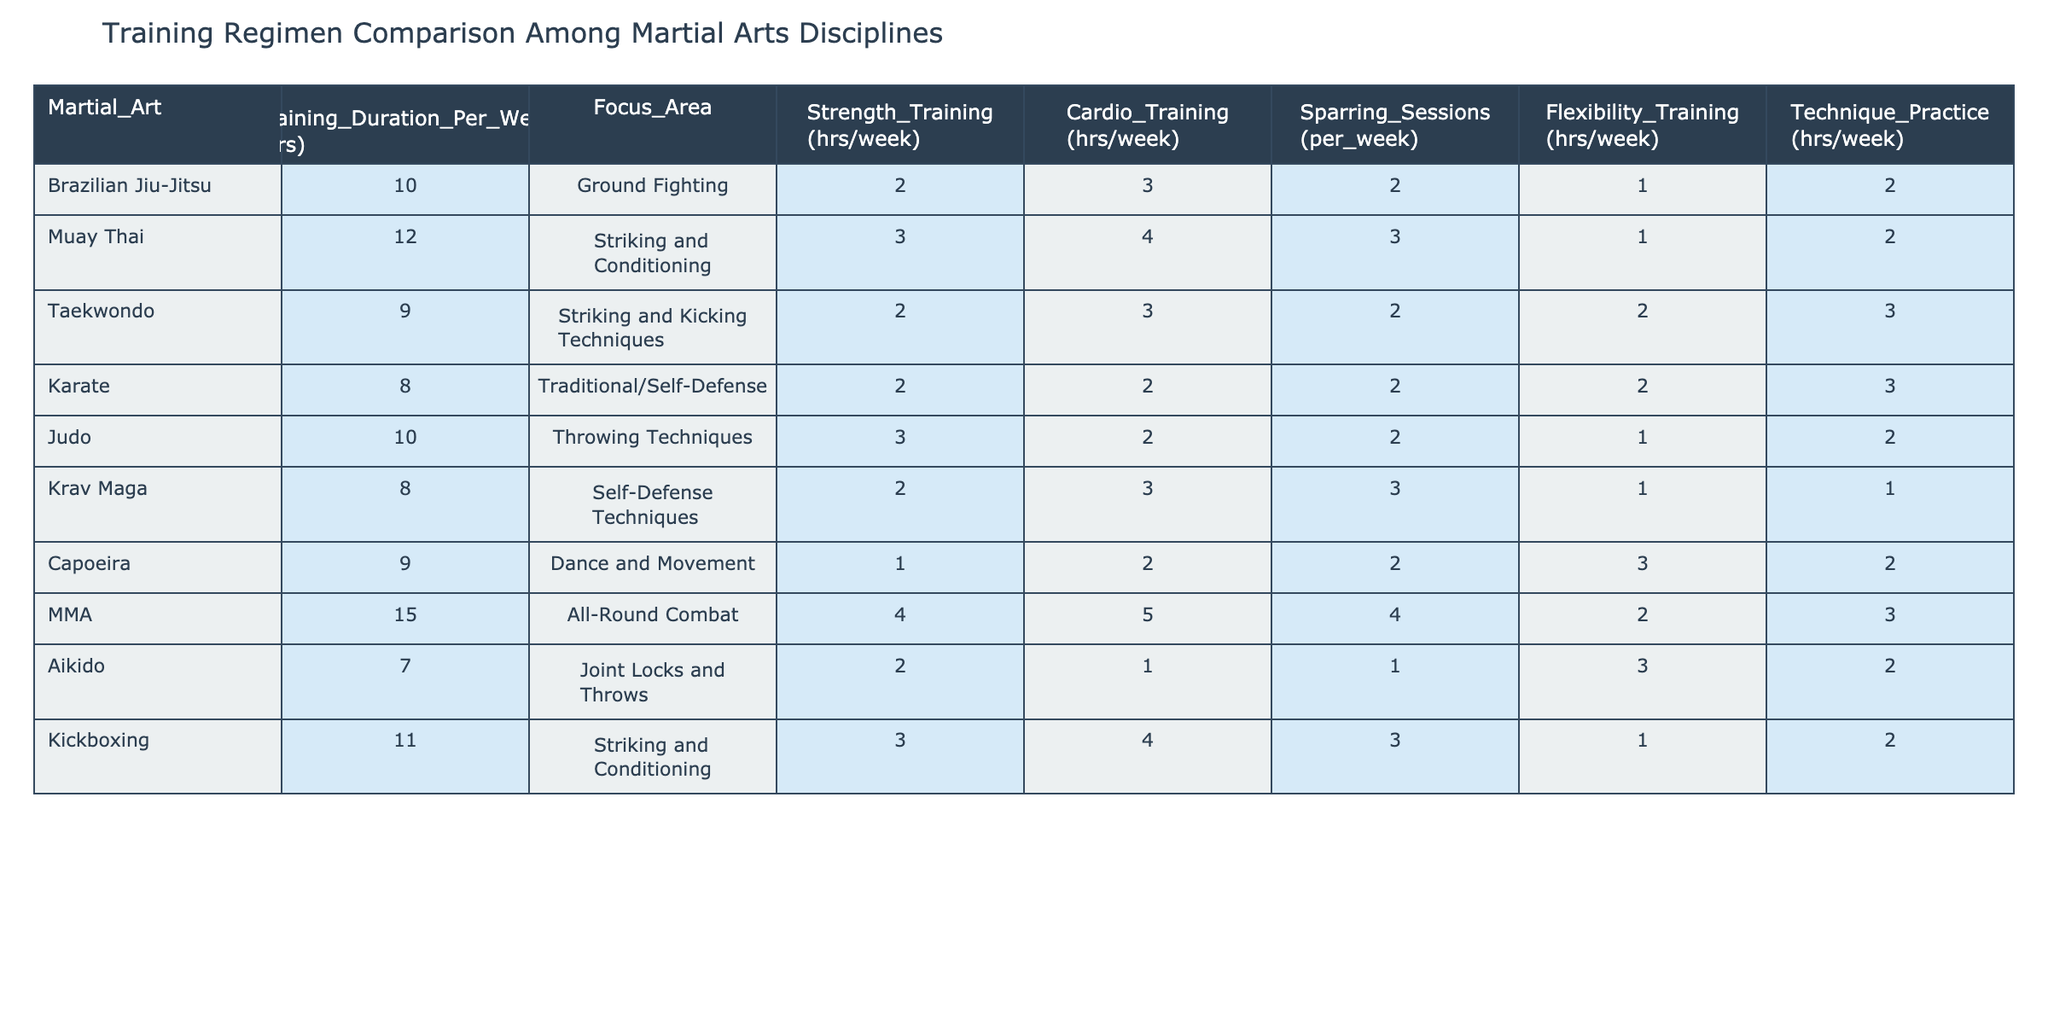What is the focus area of Taekwondo? The focus area of Taekwondo is identified in the table under the "Focus_Area" column corresponding to Taekwondo. It states "Striking and Kicking Techniques."
Answer: Striking and Kicking Techniques Which martial art has the highest training duration per week? To find this, we look through the "Training_Duration_Per_Week (hrs)" column. The highest value is 15 hours for MMA.
Answer: MMA Are there more cardio training hours in Muay Thai than in Judo? By comparing the "Cardio_Training (hrs/week)" values, Muay Thai has 4 hours and Judo has 2 hours. Since 4 > 2, the answer is yes.
Answer: Yes What is the combined total of sparring sessions per week for both Brazilian Jiu-Jitsu and Krav Maga? First, we find the sparring sessions for Brazilian Jiu-Jitsu (2 sessions) and Krav Maga (3 sessions). Then we add them: 2 + 3 = 5 sessions.
Answer: 5 Which martial art combines the highest amount of technique practice and flexibility training? We check the "Technique_Practice (hrs/week)" and "Flexibility_Training (hrs/week)" for each martial art, add them together, and find the highest. For MMA, it's 3 + 2 = 5. For Capoeira, it's 2 + 3 = 5. Others are lower. Thus, the answer for the highest sum is a tie between MMA and Capoeira, both with a total of 5 hours.
Answer: MMA and Capoeira 